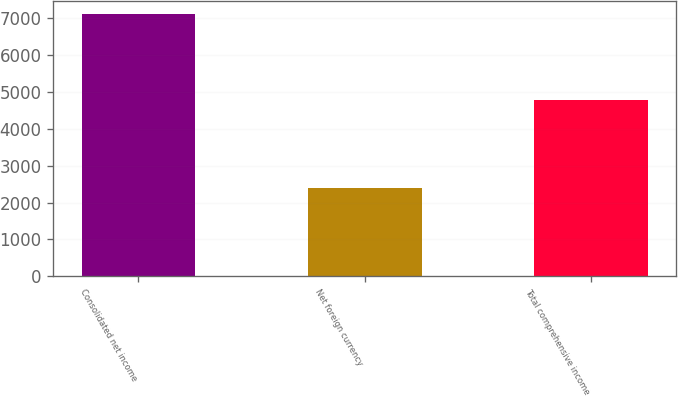Convert chart. <chart><loc_0><loc_0><loc_500><loc_500><bar_chart><fcel>Consolidated net income<fcel>Net foreign currency<fcel>Total comprehensive income<nl><fcel>7124<fcel>2382<fcel>4774<nl></chart> 